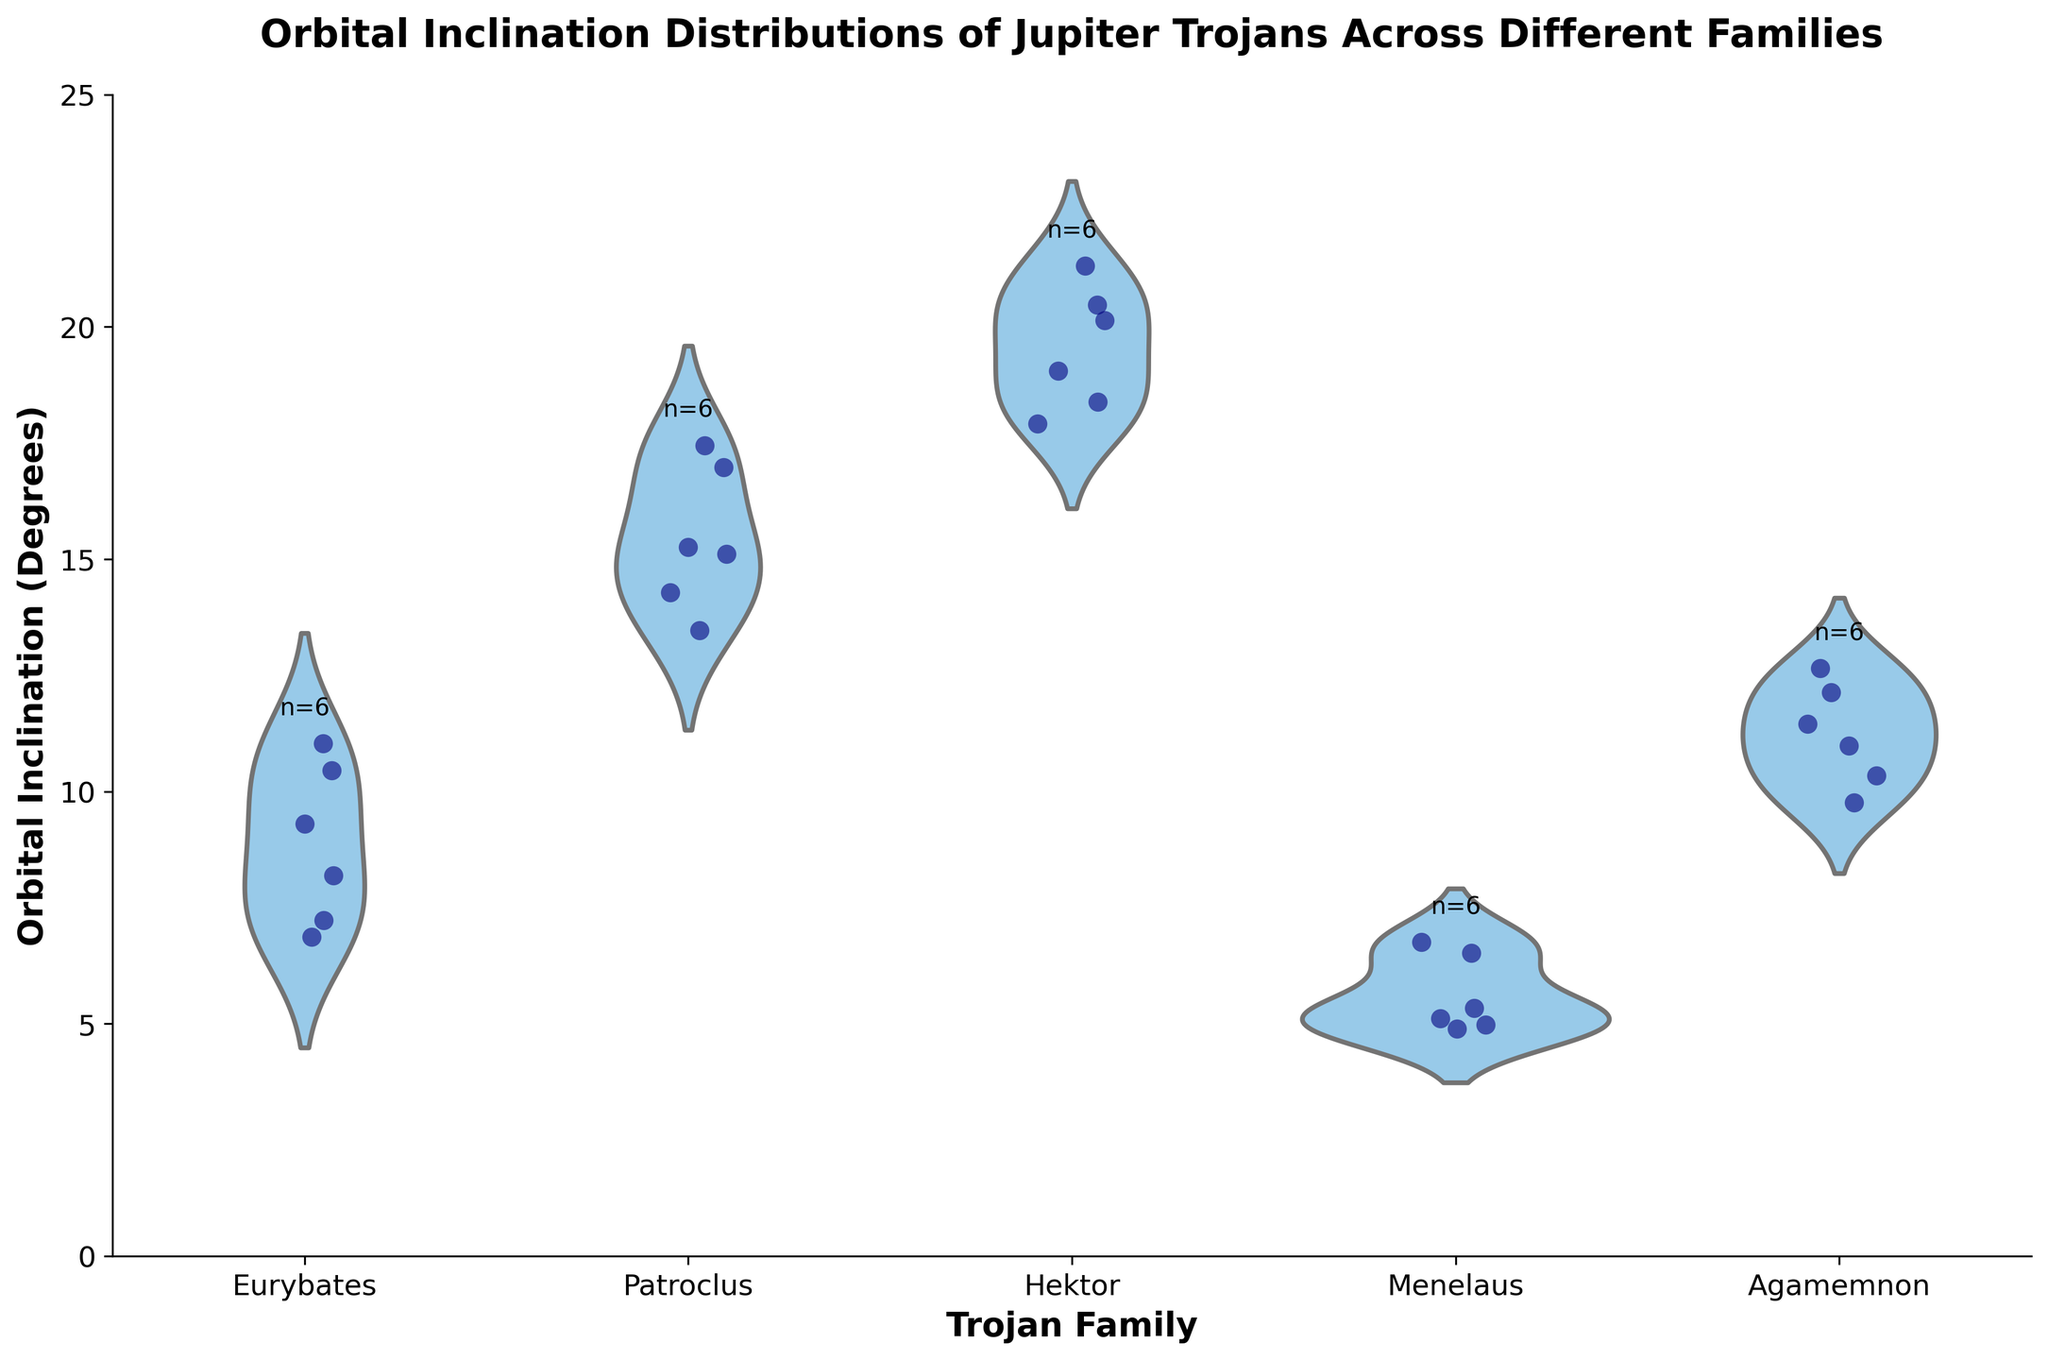How many Trojan families are represented in the figure? The x-axis of the figure lists different Trojan families. Count the unique family names (Eurybates, Patroclus, Hektor, Menelaus, Agamemnon) shown on the x-axis.
Answer: 5 What is the general trend you observe in the orbital inclination of Menelaus family? By looking at the position of points and the distribution shape of Menelaus, it's clear that their orbital inclinations are relatively low compared to other families. Most points are grouped in the lower range around 4.5 to 6.5 degrees.
Answer: Inclinations are relatively low Which Trojan family has the widest range of orbital inclination values? Observe the height of the violin plots, which indicates the range of the data. The Hektor family has a taller violin plot, indicating a wider range of orbital inclinations.
Answer: Hektor What is the approximate median orbital inclination for the Eurybates family? The median can be inferred from the central peak of the violin plot. For the Eurybates family, the central bulge is around ~8-9 degrees.
Answer: ~8-9 degrees Between Patroclus and Agamemnon, which family has higher overall orbital inclinations? Compare the heights and central concentrations of the violin plots for Patroclus and Agamemnon. Patroclus family values start higher above 13 degrees, while Agamemnon’s are centered around 10-12 degrees.
Answer: Patroclus What is the maximum orbital inclination value for the Hektor family? Observe the highest point of the jittered points and the violin plot for Hektor. The highest data point lies around 21 degrees.
Answer: ~21 degrees How many data points are there for the Eurybates family? Each family’s specific data point count is labeled above its respective violin plot. Look for the number above the Eurybates plot.
Answer: 6 Which family has the smallest number of data points, and how many? Identify the smallest number label above the violin plots. Menelaus and Eurybates both have "n=6" but only Menelaus's inclination values are visibly lower and, therefore, more distinctly recognizable.
Answer: Menelaus, 6 How do the distributions of orbital inclinations differ between Agamemnon and Menelaus families? Compare the shapes and spread of the violin plots for Agamemnon and Menelaus. Agamemnon shows a wider spread from around 9.5 to 12.5 degrees while Menelaus’s values are tightly clustered around 5-6.5 degrees.
Answer: Agamemnon has a wider spread; Menelaus is more clustered 